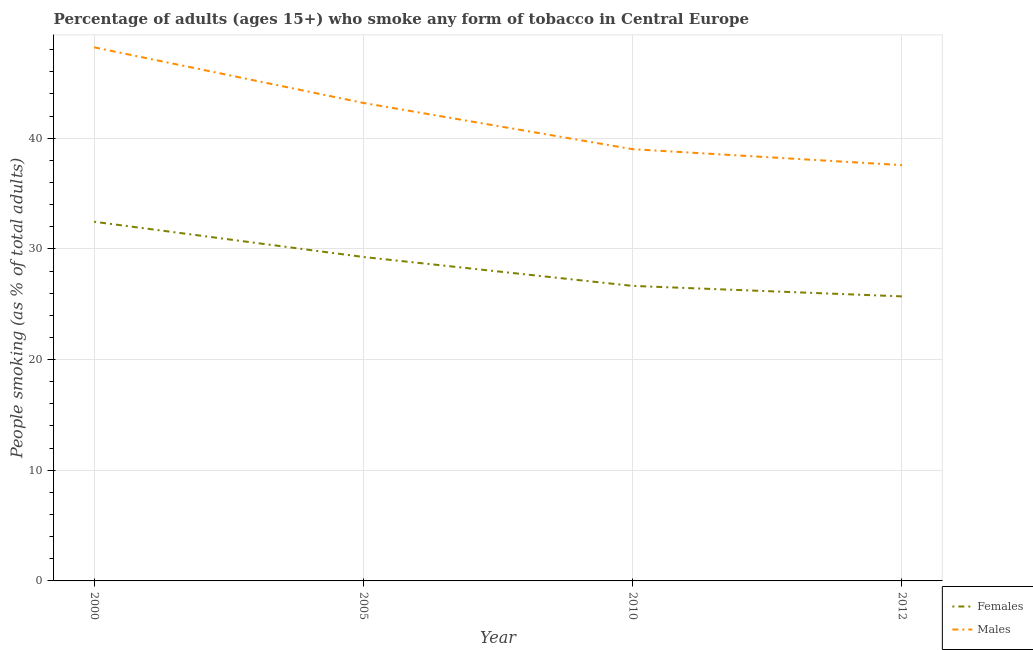How many different coloured lines are there?
Your response must be concise. 2. Is the number of lines equal to the number of legend labels?
Make the answer very short. Yes. What is the percentage of males who smoke in 2010?
Your answer should be compact. 39.01. Across all years, what is the maximum percentage of males who smoke?
Your answer should be compact. 48.21. Across all years, what is the minimum percentage of males who smoke?
Offer a terse response. 37.57. In which year was the percentage of females who smoke maximum?
Give a very brief answer. 2000. What is the total percentage of females who smoke in the graph?
Ensure brevity in your answer.  114.08. What is the difference between the percentage of males who smoke in 2005 and that in 2012?
Give a very brief answer. 5.62. What is the difference between the percentage of females who smoke in 2012 and the percentage of males who smoke in 2000?
Provide a succinct answer. -22.5. What is the average percentage of males who smoke per year?
Provide a succinct answer. 41.99. In the year 2000, what is the difference between the percentage of males who smoke and percentage of females who smoke?
Give a very brief answer. 15.76. In how many years, is the percentage of males who smoke greater than 32 %?
Give a very brief answer. 4. What is the ratio of the percentage of males who smoke in 2005 to that in 2010?
Your response must be concise. 1.11. Is the percentage of females who smoke in 2010 less than that in 2012?
Provide a succinct answer. No. Is the difference between the percentage of females who smoke in 2000 and 2005 greater than the difference between the percentage of males who smoke in 2000 and 2005?
Your answer should be compact. No. What is the difference between the highest and the second highest percentage of females who smoke?
Offer a very short reply. 3.18. What is the difference between the highest and the lowest percentage of females who smoke?
Your response must be concise. 6.74. Does the percentage of females who smoke monotonically increase over the years?
Provide a short and direct response. No. Is the percentage of females who smoke strictly greater than the percentage of males who smoke over the years?
Make the answer very short. No. Does the graph contain any zero values?
Your answer should be very brief. No. How many legend labels are there?
Your response must be concise. 2. What is the title of the graph?
Keep it short and to the point. Percentage of adults (ages 15+) who smoke any form of tobacco in Central Europe. Does "National Visitors" appear as one of the legend labels in the graph?
Give a very brief answer. No. What is the label or title of the X-axis?
Your answer should be very brief. Year. What is the label or title of the Y-axis?
Your response must be concise. People smoking (as % of total adults). What is the People smoking (as % of total adults) of Females in 2000?
Your response must be concise. 32.45. What is the People smoking (as % of total adults) in Males in 2000?
Provide a short and direct response. 48.21. What is the People smoking (as % of total adults) in Females in 2005?
Your answer should be very brief. 29.27. What is the People smoking (as % of total adults) of Males in 2005?
Provide a succinct answer. 43.18. What is the People smoking (as % of total adults) in Females in 2010?
Provide a succinct answer. 26.65. What is the People smoking (as % of total adults) of Males in 2010?
Make the answer very short. 39.01. What is the People smoking (as % of total adults) in Females in 2012?
Provide a short and direct response. 25.71. What is the People smoking (as % of total adults) of Males in 2012?
Your answer should be compact. 37.57. Across all years, what is the maximum People smoking (as % of total adults) of Females?
Your answer should be compact. 32.45. Across all years, what is the maximum People smoking (as % of total adults) in Males?
Give a very brief answer. 48.21. Across all years, what is the minimum People smoking (as % of total adults) in Females?
Make the answer very short. 25.71. Across all years, what is the minimum People smoking (as % of total adults) of Males?
Offer a terse response. 37.57. What is the total People smoking (as % of total adults) of Females in the graph?
Give a very brief answer. 114.08. What is the total People smoking (as % of total adults) of Males in the graph?
Your answer should be very brief. 167.97. What is the difference between the People smoking (as % of total adults) of Females in 2000 and that in 2005?
Your answer should be very brief. 3.18. What is the difference between the People smoking (as % of total adults) in Males in 2000 and that in 2005?
Provide a short and direct response. 5.02. What is the difference between the People smoking (as % of total adults) of Females in 2000 and that in 2010?
Your response must be concise. 5.8. What is the difference between the People smoking (as % of total adults) in Males in 2000 and that in 2010?
Your response must be concise. 9.2. What is the difference between the People smoking (as % of total adults) of Females in 2000 and that in 2012?
Provide a succinct answer. 6.74. What is the difference between the People smoking (as % of total adults) in Males in 2000 and that in 2012?
Your answer should be very brief. 10.64. What is the difference between the People smoking (as % of total adults) of Females in 2005 and that in 2010?
Provide a short and direct response. 2.61. What is the difference between the People smoking (as % of total adults) of Males in 2005 and that in 2010?
Provide a short and direct response. 4.18. What is the difference between the People smoking (as % of total adults) of Females in 2005 and that in 2012?
Offer a very short reply. 3.56. What is the difference between the People smoking (as % of total adults) in Males in 2005 and that in 2012?
Give a very brief answer. 5.62. What is the difference between the People smoking (as % of total adults) of Females in 2010 and that in 2012?
Offer a very short reply. 0.95. What is the difference between the People smoking (as % of total adults) in Males in 2010 and that in 2012?
Offer a very short reply. 1.44. What is the difference between the People smoking (as % of total adults) in Females in 2000 and the People smoking (as % of total adults) in Males in 2005?
Your answer should be very brief. -10.73. What is the difference between the People smoking (as % of total adults) of Females in 2000 and the People smoking (as % of total adults) of Males in 2010?
Provide a succinct answer. -6.56. What is the difference between the People smoking (as % of total adults) in Females in 2000 and the People smoking (as % of total adults) in Males in 2012?
Your answer should be compact. -5.12. What is the difference between the People smoking (as % of total adults) in Females in 2005 and the People smoking (as % of total adults) in Males in 2010?
Your answer should be very brief. -9.74. What is the difference between the People smoking (as % of total adults) in Females in 2005 and the People smoking (as % of total adults) in Males in 2012?
Make the answer very short. -8.3. What is the difference between the People smoking (as % of total adults) in Females in 2010 and the People smoking (as % of total adults) in Males in 2012?
Offer a terse response. -10.91. What is the average People smoking (as % of total adults) of Females per year?
Your response must be concise. 28.52. What is the average People smoking (as % of total adults) of Males per year?
Your answer should be compact. 41.99. In the year 2000, what is the difference between the People smoking (as % of total adults) of Females and People smoking (as % of total adults) of Males?
Give a very brief answer. -15.76. In the year 2005, what is the difference between the People smoking (as % of total adults) of Females and People smoking (as % of total adults) of Males?
Your answer should be very brief. -13.92. In the year 2010, what is the difference between the People smoking (as % of total adults) of Females and People smoking (as % of total adults) of Males?
Ensure brevity in your answer.  -12.35. In the year 2012, what is the difference between the People smoking (as % of total adults) in Females and People smoking (as % of total adults) in Males?
Make the answer very short. -11.86. What is the ratio of the People smoking (as % of total adults) of Females in 2000 to that in 2005?
Give a very brief answer. 1.11. What is the ratio of the People smoking (as % of total adults) in Males in 2000 to that in 2005?
Offer a terse response. 1.12. What is the ratio of the People smoking (as % of total adults) in Females in 2000 to that in 2010?
Make the answer very short. 1.22. What is the ratio of the People smoking (as % of total adults) of Males in 2000 to that in 2010?
Make the answer very short. 1.24. What is the ratio of the People smoking (as % of total adults) in Females in 2000 to that in 2012?
Provide a succinct answer. 1.26. What is the ratio of the People smoking (as % of total adults) in Males in 2000 to that in 2012?
Offer a very short reply. 1.28. What is the ratio of the People smoking (as % of total adults) of Females in 2005 to that in 2010?
Ensure brevity in your answer.  1.1. What is the ratio of the People smoking (as % of total adults) of Males in 2005 to that in 2010?
Your answer should be very brief. 1.11. What is the ratio of the People smoking (as % of total adults) of Females in 2005 to that in 2012?
Offer a terse response. 1.14. What is the ratio of the People smoking (as % of total adults) in Males in 2005 to that in 2012?
Make the answer very short. 1.15. What is the ratio of the People smoking (as % of total adults) of Females in 2010 to that in 2012?
Offer a terse response. 1.04. What is the ratio of the People smoking (as % of total adults) of Males in 2010 to that in 2012?
Ensure brevity in your answer.  1.04. What is the difference between the highest and the second highest People smoking (as % of total adults) in Females?
Make the answer very short. 3.18. What is the difference between the highest and the second highest People smoking (as % of total adults) of Males?
Your response must be concise. 5.02. What is the difference between the highest and the lowest People smoking (as % of total adults) in Females?
Offer a terse response. 6.74. What is the difference between the highest and the lowest People smoking (as % of total adults) of Males?
Give a very brief answer. 10.64. 